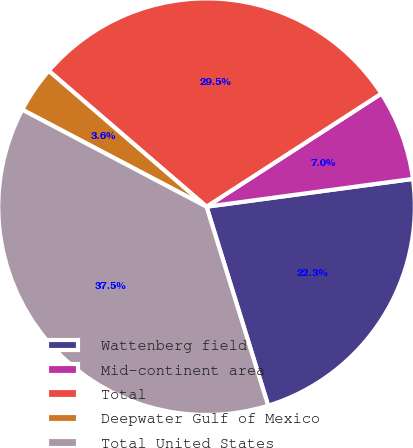Convert chart to OTSL. <chart><loc_0><loc_0><loc_500><loc_500><pie_chart><fcel>Wattenberg field<fcel>Mid-continent area<fcel>Total<fcel>Deepwater Gulf of Mexico<fcel>Total United States<nl><fcel>22.35%<fcel>7.01%<fcel>29.55%<fcel>3.6%<fcel>37.5%<nl></chart> 